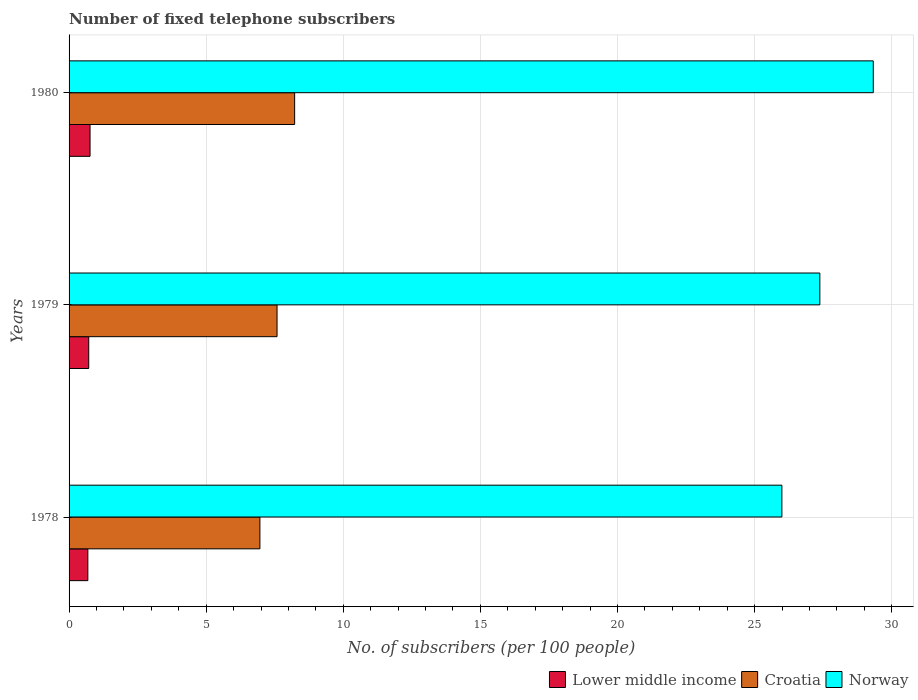How many groups of bars are there?
Provide a succinct answer. 3. Are the number of bars per tick equal to the number of legend labels?
Your answer should be very brief. Yes. Are the number of bars on each tick of the Y-axis equal?
Offer a very short reply. Yes. How many bars are there on the 3rd tick from the bottom?
Ensure brevity in your answer.  3. What is the label of the 3rd group of bars from the top?
Offer a very short reply. 1978. In how many cases, is the number of bars for a given year not equal to the number of legend labels?
Give a very brief answer. 0. What is the number of fixed telephone subscribers in Croatia in 1980?
Offer a very short reply. 8.23. Across all years, what is the maximum number of fixed telephone subscribers in Croatia?
Ensure brevity in your answer.  8.23. Across all years, what is the minimum number of fixed telephone subscribers in Lower middle income?
Give a very brief answer. 0.68. In which year was the number of fixed telephone subscribers in Croatia maximum?
Keep it short and to the point. 1980. In which year was the number of fixed telephone subscribers in Croatia minimum?
Provide a short and direct response. 1978. What is the total number of fixed telephone subscribers in Croatia in the graph?
Keep it short and to the point. 22.77. What is the difference between the number of fixed telephone subscribers in Norway in 1978 and that in 1979?
Provide a succinct answer. -1.38. What is the difference between the number of fixed telephone subscribers in Croatia in 1980 and the number of fixed telephone subscribers in Norway in 1979?
Your answer should be very brief. -19.15. What is the average number of fixed telephone subscribers in Croatia per year?
Keep it short and to the point. 7.59. In the year 1979, what is the difference between the number of fixed telephone subscribers in Norway and number of fixed telephone subscribers in Croatia?
Your answer should be very brief. 19.79. What is the ratio of the number of fixed telephone subscribers in Norway in 1978 to that in 1979?
Your answer should be compact. 0.95. Is the number of fixed telephone subscribers in Lower middle income in 1979 less than that in 1980?
Provide a succinct answer. Yes. Is the difference between the number of fixed telephone subscribers in Norway in 1979 and 1980 greater than the difference between the number of fixed telephone subscribers in Croatia in 1979 and 1980?
Ensure brevity in your answer.  No. What is the difference between the highest and the second highest number of fixed telephone subscribers in Norway?
Provide a succinct answer. 1.95. What is the difference between the highest and the lowest number of fixed telephone subscribers in Croatia?
Provide a succinct answer. 1.27. Is the sum of the number of fixed telephone subscribers in Lower middle income in 1978 and 1979 greater than the maximum number of fixed telephone subscribers in Croatia across all years?
Provide a succinct answer. No. What does the 3rd bar from the top in 1979 represents?
Provide a short and direct response. Lower middle income. What does the 2nd bar from the bottom in 1978 represents?
Keep it short and to the point. Croatia. How many bars are there?
Provide a succinct answer. 9. Are all the bars in the graph horizontal?
Your answer should be compact. Yes. Are the values on the major ticks of X-axis written in scientific E-notation?
Offer a very short reply. No. Where does the legend appear in the graph?
Your response must be concise. Bottom right. How many legend labels are there?
Offer a terse response. 3. How are the legend labels stacked?
Make the answer very short. Horizontal. What is the title of the graph?
Offer a terse response. Number of fixed telephone subscribers. Does "Bulgaria" appear as one of the legend labels in the graph?
Provide a succinct answer. No. What is the label or title of the X-axis?
Your answer should be compact. No. of subscribers (per 100 people). What is the No. of subscribers (per 100 people) of Lower middle income in 1978?
Ensure brevity in your answer.  0.68. What is the No. of subscribers (per 100 people) in Croatia in 1978?
Offer a terse response. 6.96. What is the No. of subscribers (per 100 people) of Norway in 1978?
Ensure brevity in your answer.  25.99. What is the No. of subscribers (per 100 people) in Lower middle income in 1979?
Offer a terse response. 0.72. What is the No. of subscribers (per 100 people) of Croatia in 1979?
Make the answer very short. 7.58. What is the No. of subscribers (per 100 people) in Norway in 1979?
Offer a terse response. 27.38. What is the No. of subscribers (per 100 people) of Lower middle income in 1980?
Provide a succinct answer. 0.77. What is the No. of subscribers (per 100 people) of Croatia in 1980?
Your response must be concise. 8.23. What is the No. of subscribers (per 100 people) in Norway in 1980?
Your answer should be compact. 29.33. Across all years, what is the maximum No. of subscribers (per 100 people) in Lower middle income?
Offer a very short reply. 0.77. Across all years, what is the maximum No. of subscribers (per 100 people) in Croatia?
Ensure brevity in your answer.  8.23. Across all years, what is the maximum No. of subscribers (per 100 people) of Norway?
Provide a short and direct response. 29.33. Across all years, what is the minimum No. of subscribers (per 100 people) in Lower middle income?
Give a very brief answer. 0.68. Across all years, what is the minimum No. of subscribers (per 100 people) of Croatia?
Ensure brevity in your answer.  6.96. Across all years, what is the minimum No. of subscribers (per 100 people) in Norway?
Your answer should be very brief. 25.99. What is the total No. of subscribers (per 100 people) of Lower middle income in the graph?
Offer a very short reply. 2.17. What is the total No. of subscribers (per 100 people) of Croatia in the graph?
Give a very brief answer. 22.77. What is the total No. of subscribers (per 100 people) in Norway in the graph?
Give a very brief answer. 82.7. What is the difference between the No. of subscribers (per 100 people) in Lower middle income in 1978 and that in 1979?
Keep it short and to the point. -0.03. What is the difference between the No. of subscribers (per 100 people) of Croatia in 1978 and that in 1979?
Provide a succinct answer. -0.62. What is the difference between the No. of subscribers (per 100 people) of Norway in 1978 and that in 1979?
Provide a succinct answer. -1.38. What is the difference between the No. of subscribers (per 100 people) of Lower middle income in 1978 and that in 1980?
Provide a succinct answer. -0.08. What is the difference between the No. of subscribers (per 100 people) of Croatia in 1978 and that in 1980?
Your response must be concise. -1.27. What is the difference between the No. of subscribers (per 100 people) of Norway in 1978 and that in 1980?
Offer a very short reply. -3.33. What is the difference between the No. of subscribers (per 100 people) of Lower middle income in 1979 and that in 1980?
Provide a short and direct response. -0.05. What is the difference between the No. of subscribers (per 100 people) in Croatia in 1979 and that in 1980?
Provide a short and direct response. -0.64. What is the difference between the No. of subscribers (per 100 people) in Norway in 1979 and that in 1980?
Provide a short and direct response. -1.95. What is the difference between the No. of subscribers (per 100 people) in Lower middle income in 1978 and the No. of subscribers (per 100 people) in Croatia in 1979?
Your answer should be compact. -6.9. What is the difference between the No. of subscribers (per 100 people) of Lower middle income in 1978 and the No. of subscribers (per 100 people) of Norway in 1979?
Provide a short and direct response. -26.69. What is the difference between the No. of subscribers (per 100 people) in Croatia in 1978 and the No. of subscribers (per 100 people) in Norway in 1979?
Ensure brevity in your answer.  -20.42. What is the difference between the No. of subscribers (per 100 people) in Lower middle income in 1978 and the No. of subscribers (per 100 people) in Croatia in 1980?
Your answer should be compact. -7.54. What is the difference between the No. of subscribers (per 100 people) of Lower middle income in 1978 and the No. of subscribers (per 100 people) of Norway in 1980?
Offer a very short reply. -28.64. What is the difference between the No. of subscribers (per 100 people) of Croatia in 1978 and the No. of subscribers (per 100 people) of Norway in 1980?
Provide a succinct answer. -22.37. What is the difference between the No. of subscribers (per 100 people) in Lower middle income in 1979 and the No. of subscribers (per 100 people) in Croatia in 1980?
Provide a succinct answer. -7.51. What is the difference between the No. of subscribers (per 100 people) in Lower middle income in 1979 and the No. of subscribers (per 100 people) in Norway in 1980?
Make the answer very short. -28.61. What is the difference between the No. of subscribers (per 100 people) of Croatia in 1979 and the No. of subscribers (per 100 people) of Norway in 1980?
Give a very brief answer. -21.74. What is the average No. of subscribers (per 100 people) of Lower middle income per year?
Your answer should be compact. 0.72. What is the average No. of subscribers (per 100 people) in Croatia per year?
Give a very brief answer. 7.59. What is the average No. of subscribers (per 100 people) in Norway per year?
Offer a very short reply. 27.57. In the year 1978, what is the difference between the No. of subscribers (per 100 people) in Lower middle income and No. of subscribers (per 100 people) in Croatia?
Offer a terse response. -6.27. In the year 1978, what is the difference between the No. of subscribers (per 100 people) in Lower middle income and No. of subscribers (per 100 people) in Norway?
Offer a terse response. -25.31. In the year 1978, what is the difference between the No. of subscribers (per 100 people) of Croatia and No. of subscribers (per 100 people) of Norway?
Ensure brevity in your answer.  -19.04. In the year 1979, what is the difference between the No. of subscribers (per 100 people) in Lower middle income and No. of subscribers (per 100 people) in Croatia?
Your response must be concise. -6.87. In the year 1979, what is the difference between the No. of subscribers (per 100 people) in Lower middle income and No. of subscribers (per 100 people) in Norway?
Your answer should be very brief. -26.66. In the year 1979, what is the difference between the No. of subscribers (per 100 people) in Croatia and No. of subscribers (per 100 people) in Norway?
Ensure brevity in your answer.  -19.79. In the year 1980, what is the difference between the No. of subscribers (per 100 people) of Lower middle income and No. of subscribers (per 100 people) of Croatia?
Provide a short and direct response. -7.46. In the year 1980, what is the difference between the No. of subscribers (per 100 people) in Lower middle income and No. of subscribers (per 100 people) in Norway?
Your response must be concise. -28.56. In the year 1980, what is the difference between the No. of subscribers (per 100 people) of Croatia and No. of subscribers (per 100 people) of Norway?
Your answer should be very brief. -21.1. What is the ratio of the No. of subscribers (per 100 people) in Lower middle income in 1978 to that in 1979?
Your response must be concise. 0.95. What is the ratio of the No. of subscribers (per 100 people) of Croatia in 1978 to that in 1979?
Keep it short and to the point. 0.92. What is the ratio of the No. of subscribers (per 100 people) in Norway in 1978 to that in 1979?
Your answer should be very brief. 0.95. What is the ratio of the No. of subscribers (per 100 people) of Lower middle income in 1978 to that in 1980?
Offer a very short reply. 0.89. What is the ratio of the No. of subscribers (per 100 people) in Croatia in 1978 to that in 1980?
Provide a succinct answer. 0.85. What is the ratio of the No. of subscribers (per 100 people) in Norway in 1978 to that in 1980?
Ensure brevity in your answer.  0.89. What is the ratio of the No. of subscribers (per 100 people) in Lower middle income in 1979 to that in 1980?
Provide a succinct answer. 0.94. What is the ratio of the No. of subscribers (per 100 people) in Croatia in 1979 to that in 1980?
Your answer should be compact. 0.92. What is the ratio of the No. of subscribers (per 100 people) of Norway in 1979 to that in 1980?
Your response must be concise. 0.93. What is the difference between the highest and the second highest No. of subscribers (per 100 people) in Lower middle income?
Your answer should be very brief. 0.05. What is the difference between the highest and the second highest No. of subscribers (per 100 people) of Croatia?
Ensure brevity in your answer.  0.64. What is the difference between the highest and the second highest No. of subscribers (per 100 people) of Norway?
Your answer should be compact. 1.95. What is the difference between the highest and the lowest No. of subscribers (per 100 people) in Lower middle income?
Offer a very short reply. 0.08. What is the difference between the highest and the lowest No. of subscribers (per 100 people) of Croatia?
Your answer should be very brief. 1.27. What is the difference between the highest and the lowest No. of subscribers (per 100 people) in Norway?
Offer a terse response. 3.33. 